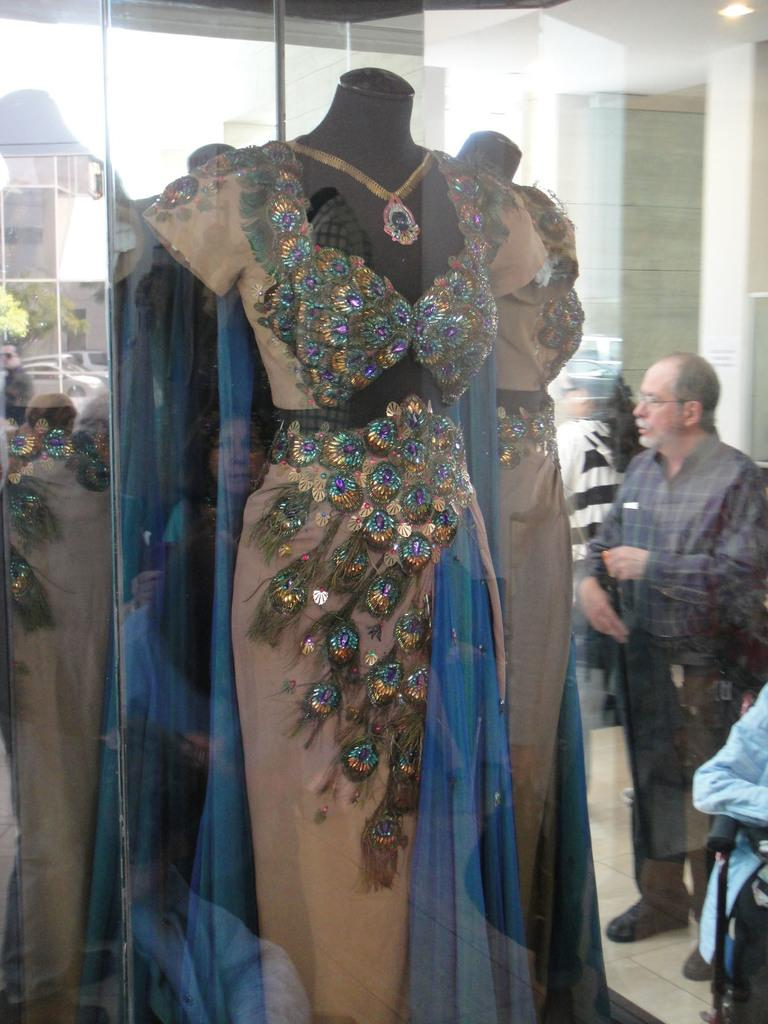What is the main subject of the image? There is a statue in the image. What is the statue wearing? The statue has a dress on it. What can be seen in the background of the image? There are persons, cars, buildings, and trees in the background of the image. Can you tell me how many potatoes are on the statue's head in the image? There are no potatoes present in the image, as the statue is wearing a dress and not a potato. Is there an icicle hanging from the statue's arm in the image? There is no icicle present in the image; the statue is wearing a dress and there is no mention of an icicle. 